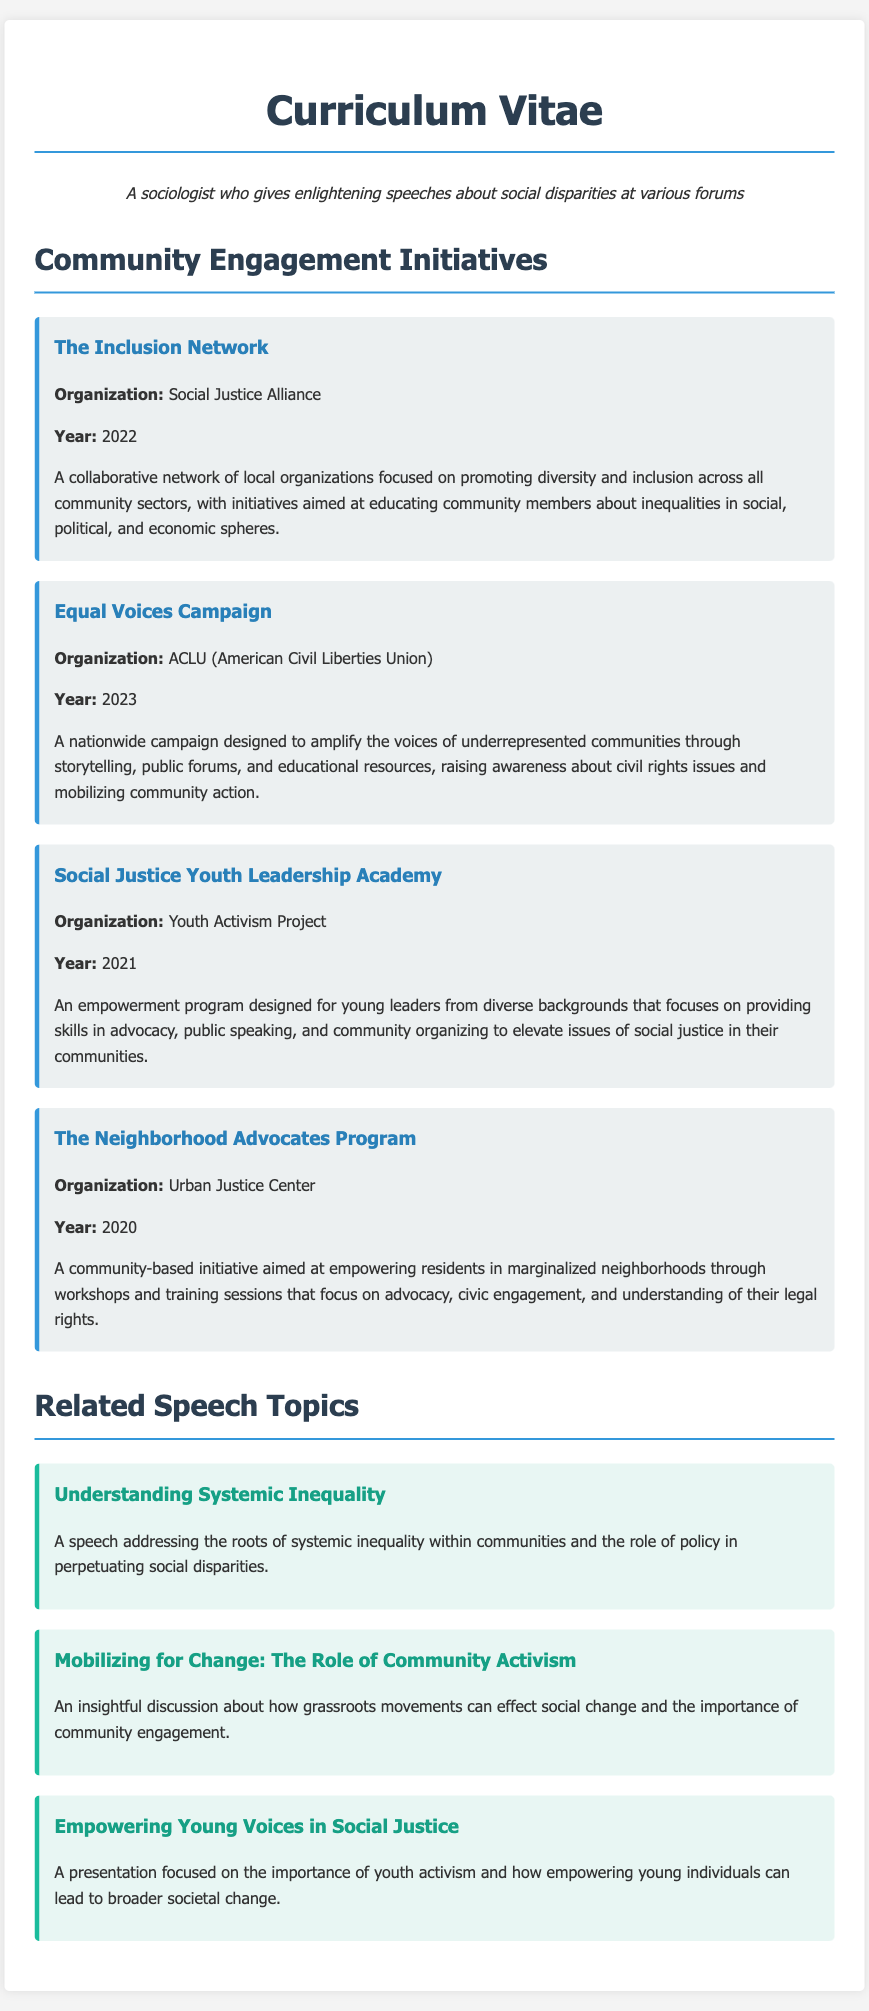What is the name of the organization behind "The Inclusion Network"? The organization is responsible for "The Inclusion Network" as listed in the document.
Answer: Social Justice Alliance In what year was the "Equal Voices Campaign" launched? The document specifies the year the campaign began.
Answer: 2023 What is the focus of the "Social Justice Youth Leadership Academy"? This initiative's description provides details on its main objective.
Answer: Advocacy, public speaking, and community organizing Which initiative aims to empower residents in marginalized neighborhoods? The initiative’s description highlights its target community.
Answer: The Neighborhood Advocates Program How many community engagement initiatives are listed in the document? The document contains a specific number of initiatives outlined in the section.
Answer: Four What is the title of a speech related to empowering young individuals? The topic lists various speeches, and this one specifically addresses youth empowerment.
Answer: Empowering Young Voices in Social Justice Which organization is associated with the "Social Justice Youth Leadership Academy"? The academy's description includes the affiliated organization.
Answer: Youth Activism Project What type of document is this? The structure and content indicate the nature of the document clearly.
Answer: Curriculum Vitae What is the main theme of the "Equal Voices Campaign"? The campaign's description provides insight into its overarching focus.
Answer: Civil rights issues 